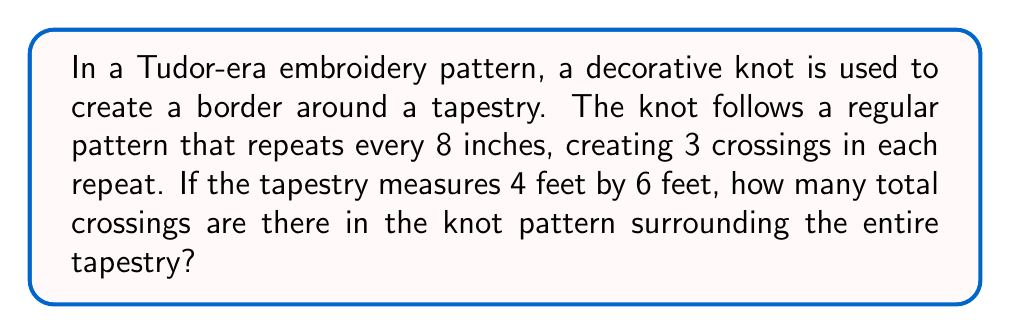Provide a solution to this math problem. Let's approach this step-by-step:

1. Convert the tapestry dimensions to inches:
   4 feet = 48 inches
   6 feet = 72 inches

2. Calculate the perimeter of the tapestry:
   Perimeter = $2(length + width) = 2(48 + 72) = 2(120) = 240$ inches

3. Determine how many pattern repeats fit around the perimeter:
   Number of repeats = $\frac{Perimeter}{Length of one repeat} = \frac{240}{8} = 30$

4. Calculate the total number of crossings:
   Crossings per repeat = 3
   Total crossings = $Crossings per repeat \times Number of repeats = 3 \times 30 = 90$

Therefore, there are 90 crossings in the knot pattern surrounding the entire tapestry.
Answer: 90 crossings 